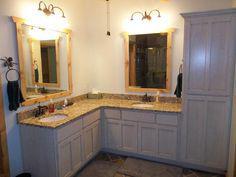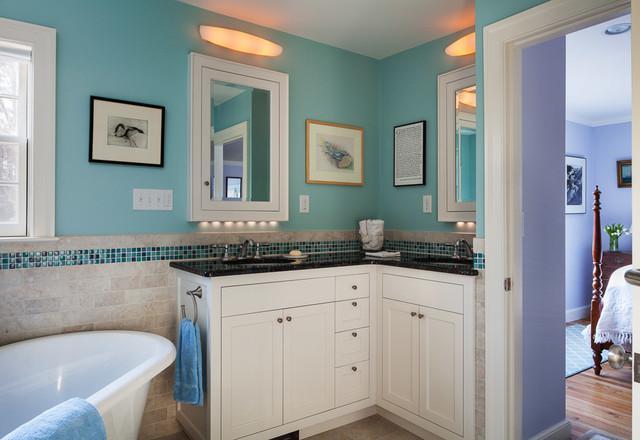The first image is the image on the left, the second image is the image on the right. Assess this claim about the two images: "Both images have different wall colors and there is a stand alone bath tub in one of them.". Correct or not? Answer yes or no. Yes. The first image is the image on the left, the second image is the image on the right. For the images shown, is this caption "Exactly one bathroom vanity unit is wrapped around a wall." true? Answer yes or no. No. 